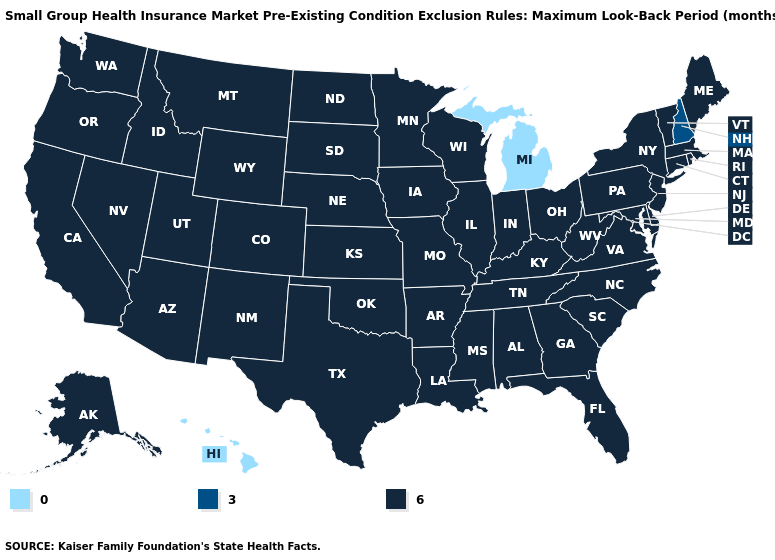What is the highest value in the USA?
Be succinct. 6. How many symbols are there in the legend?
Quick response, please. 3. Does Tennessee have the same value as Alaska?
Be succinct. Yes. What is the value of Maryland?
Give a very brief answer. 6. What is the value of Rhode Island?
Concise answer only. 6. Does Michigan have the highest value in the USA?
Be succinct. No. Name the states that have a value in the range 0?
Write a very short answer. Hawaii, Michigan. How many symbols are there in the legend?
Answer briefly. 3. Name the states that have a value in the range 3?
Be succinct. New Hampshire. Which states have the highest value in the USA?
Quick response, please. Alabama, Alaska, Arizona, Arkansas, California, Colorado, Connecticut, Delaware, Florida, Georgia, Idaho, Illinois, Indiana, Iowa, Kansas, Kentucky, Louisiana, Maine, Maryland, Massachusetts, Minnesota, Mississippi, Missouri, Montana, Nebraska, Nevada, New Jersey, New Mexico, New York, North Carolina, North Dakota, Ohio, Oklahoma, Oregon, Pennsylvania, Rhode Island, South Carolina, South Dakota, Tennessee, Texas, Utah, Vermont, Virginia, Washington, West Virginia, Wisconsin, Wyoming. Name the states that have a value in the range 6?
Keep it brief. Alabama, Alaska, Arizona, Arkansas, California, Colorado, Connecticut, Delaware, Florida, Georgia, Idaho, Illinois, Indiana, Iowa, Kansas, Kentucky, Louisiana, Maine, Maryland, Massachusetts, Minnesota, Mississippi, Missouri, Montana, Nebraska, Nevada, New Jersey, New Mexico, New York, North Carolina, North Dakota, Ohio, Oklahoma, Oregon, Pennsylvania, Rhode Island, South Carolina, South Dakota, Tennessee, Texas, Utah, Vermont, Virginia, Washington, West Virginia, Wisconsin, Wyoming. What is the value of Kansas?
Keep it brief. 6. Which states have the lowest value in the USA?
Be succinct. Hawaii, Michigan. Does Wisconsin have a higher value than Michigan?
Short answer required. Yes. 